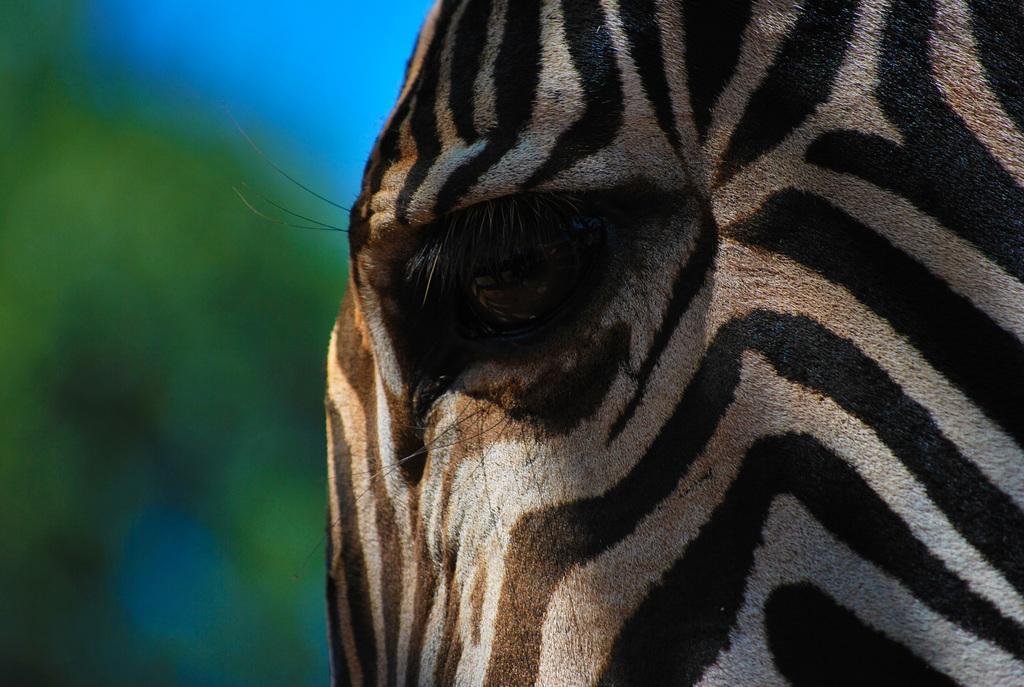Please provide a concise description of this image. In this image we can see zebra. 